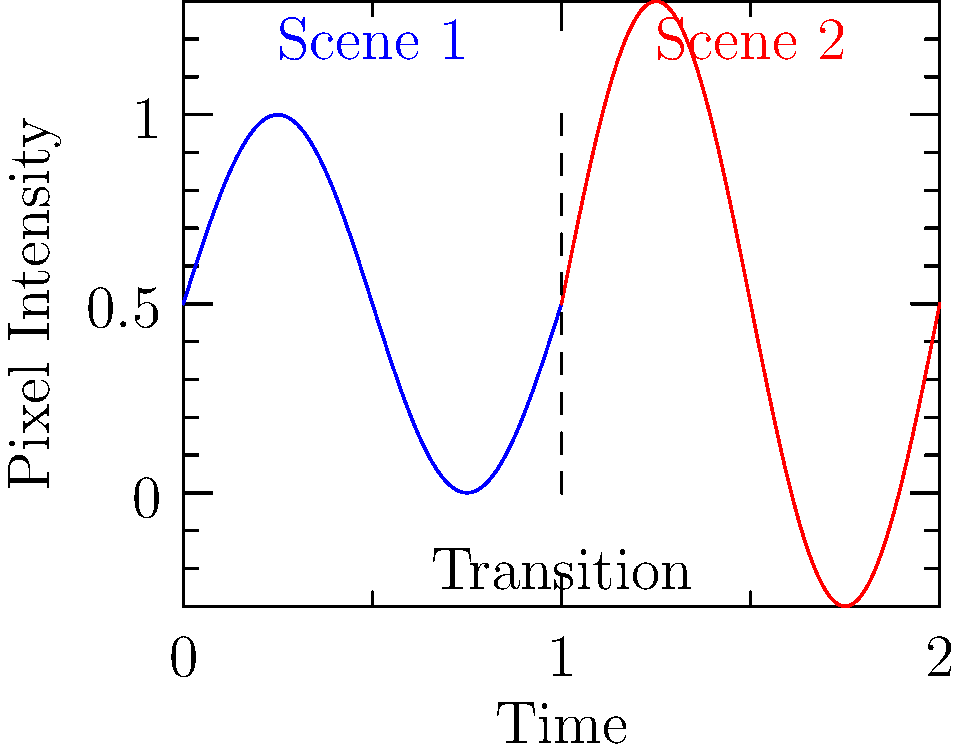In the context of detecting scene transitions in film clips through video analysis, what does the sudden change in the graph's pattern at t=1 likely represent, and how might this be useful in your screenwriting process? 1. Graph interpretation:
   - The blue curve (0 ≤ t < 1) represents the pixel intensity variation in Scene 1.
   - The red curve (1 < t ≤ 2) represents the pixel intensity variation in Scene 2.
   - The vertical dashed line at t=1 indicates a sudden change in the pattern.

2. Scene transition detection:
   - The abrupt change in the graph's pattern at t=1 likely represents a scene transition.
   - This is evident from the discontinuity in the sine wave pattern and the color change.

3. Video analysis technique:
   - This graph illustrates a common method for detecting scene changes in video analysis.
   - Algorithms analyze frame-to-frame differences in pixel intensities or other features.
   - Large, sudden changes often indicate scene transitions.

4. Relevance to screenwriting:
   - Understanding scene transitions is crucial for pacing and storytelling in screenplays.
   - This technique can help analyze existing films to study their scene structure and pacing.
   - It can also be used to visualize and refine the rhythm of scenes in your own scripts.

5. Application in Chinese cinema:
   - Mei Feng, known for his work in Chinese cinema, often uses unique scene transitions.
   - Analyzing his films using this technique could provide insights into his storytelling style.
   - This could help you incorporate similar pacing and transition techniques in your own screenplays.
Answer: A scene transition, useful for analyzing film pacing and structure in screenwriting. 